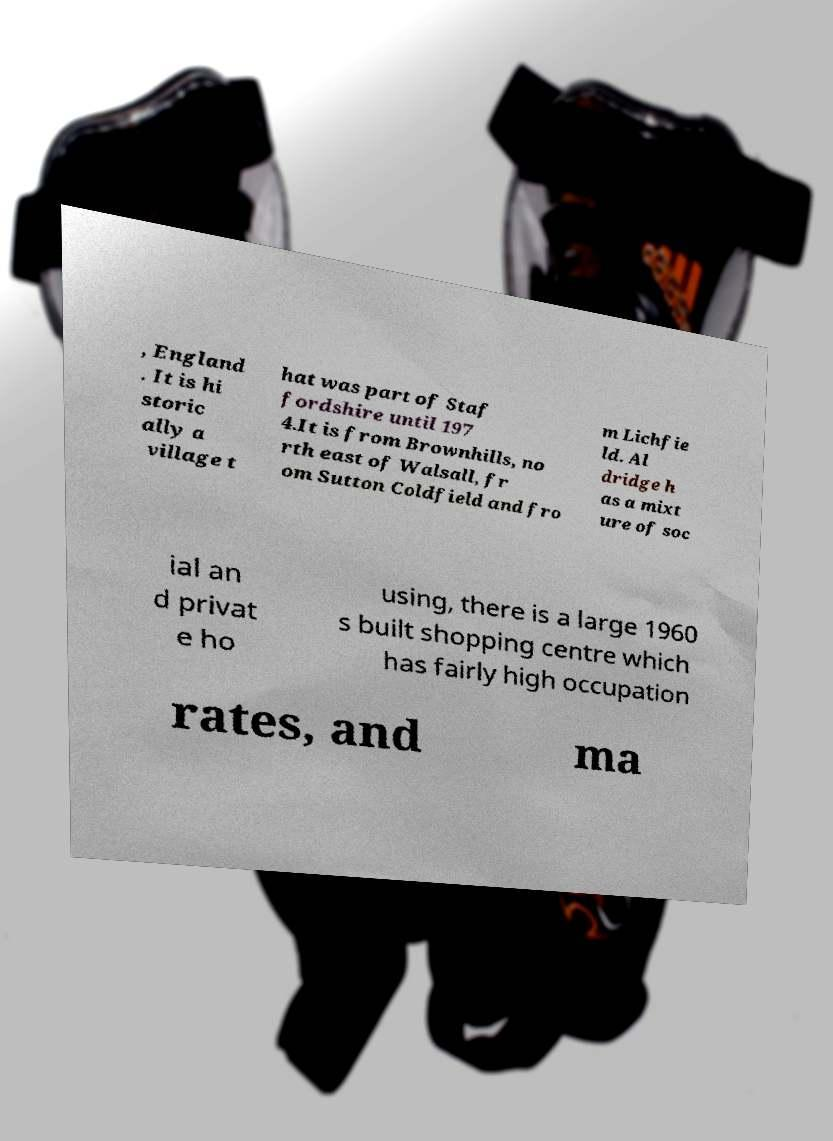There's text embedded in this image that I need extracted. Can you transcribe it verbatim? , England . It is hi storic ally a village t hat was part of Staf fordshire until 197 4.It is from Brownhills, no rth east of Walsall, fr om Sutton Coldfield and fro m Lichfie ld. Al dridge h as a mixt ure of soc ial an d privat e ho using, there is a large 1960 s built shopping centre which has fairly high occupation rates, and ma 